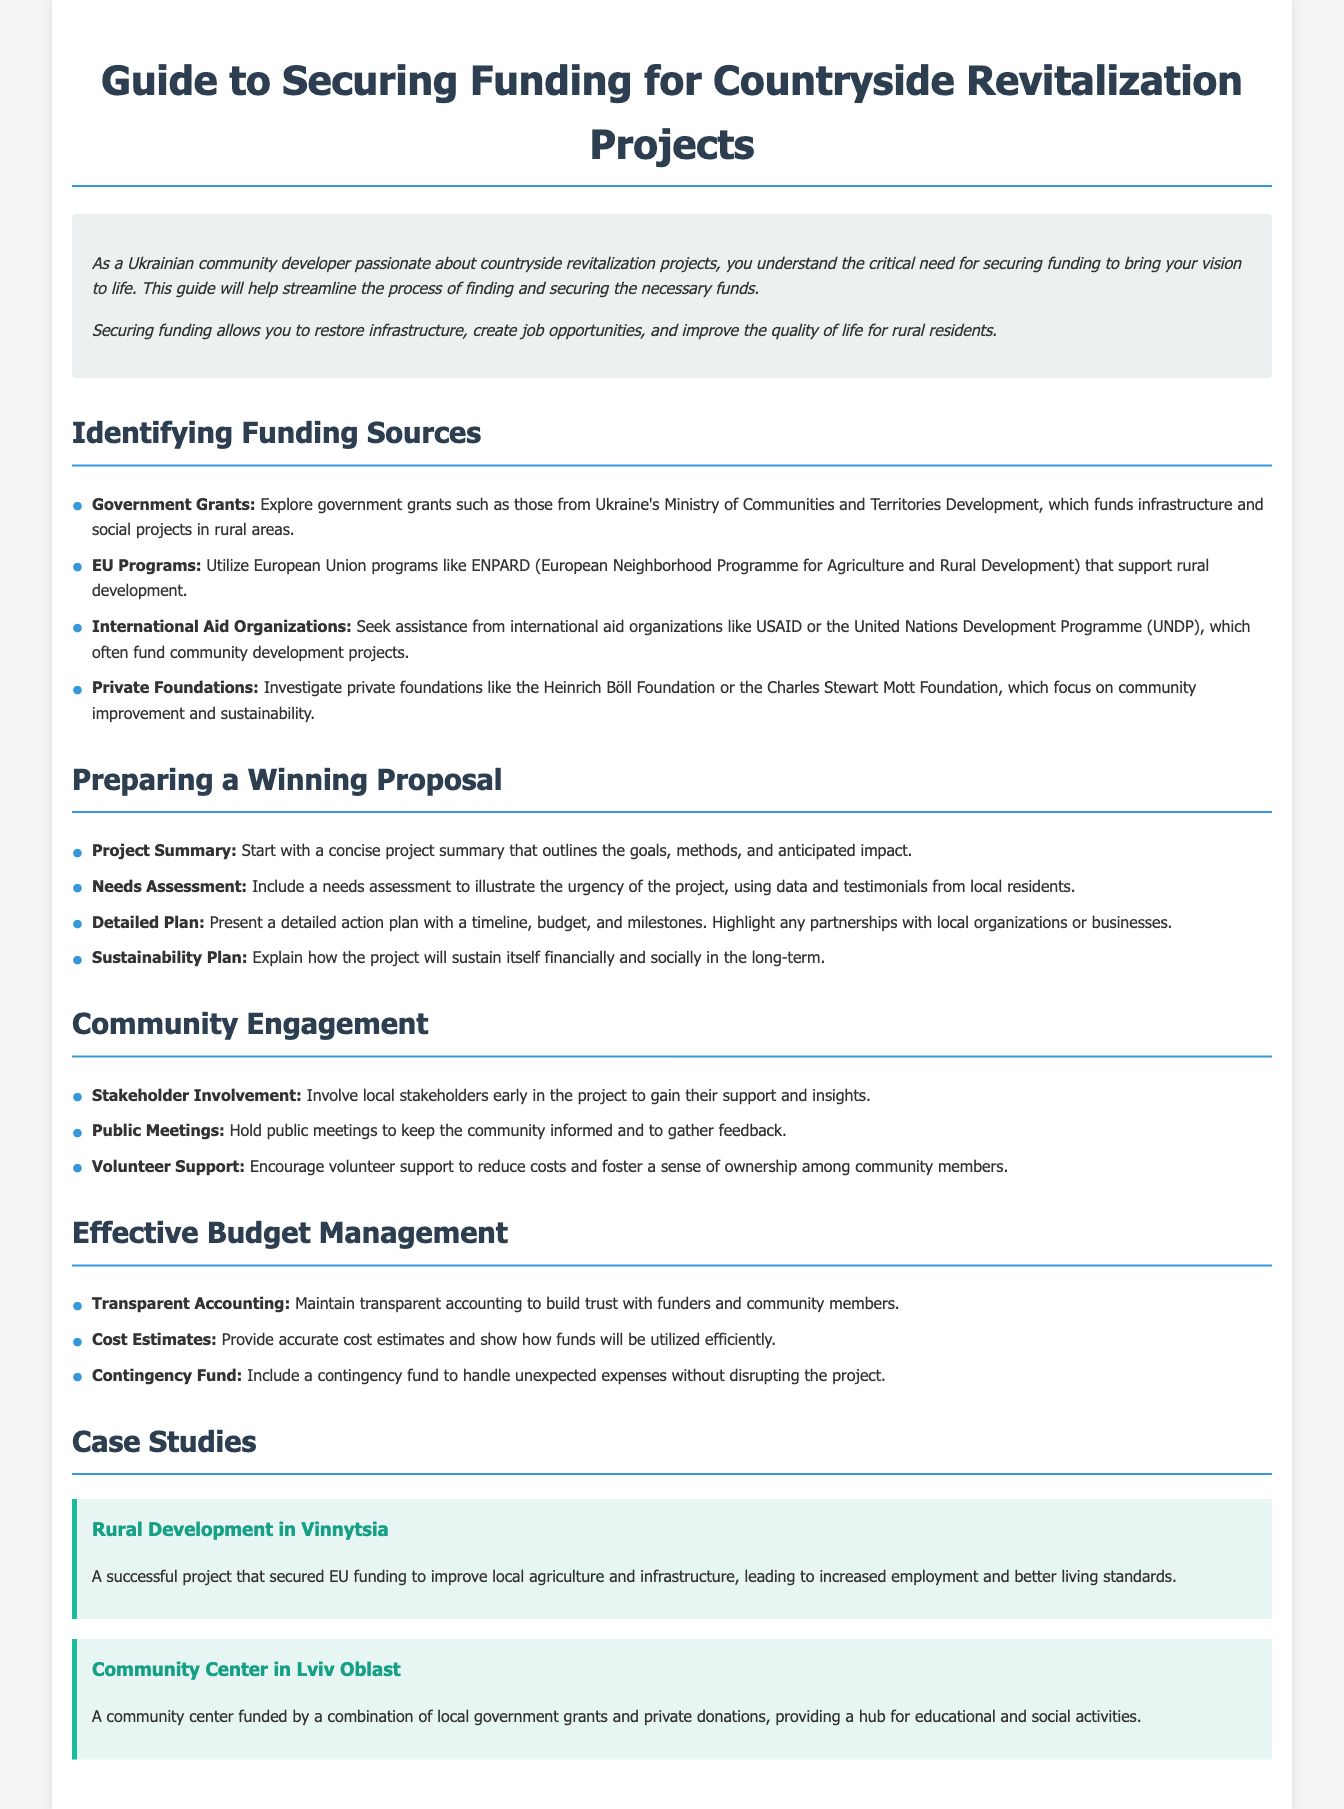What are the funding sources mentioned? The document lists several funding sources including government grants, EU programs, international aid organizations, and private foundations.
Answer: Government grants, EU programs, international aid organizations, private foundations What is one purpose of securing funding? The guide states that securing funding allows for the restoration of infrastructure, job creation, and improved quality of life.
Answer: Restore infrastructure What does the project summary need to include? The project summary should outline the goals, methods, and anticipated impact of the project.
Answer: Goals, methods, anticipated impact What should be assessed to illustrate project urgency? The needs assessment is meant to illustrate the urgency of the project using data and testimonials from local residents.
Answer: Needs assessment Which EU program is mentioned? The document mentions the European Neighborhood Programme for Agriculture and Rural Development (ENPARD) as a source of funding.
Answer: ENPARD How many case studies are provided? There are two case studies provided in the document regarding successful projects.
Answer: Two What should be included in the sustainability plan? The sustainability plan should explain how the project will sustain itself financially and socially in the long term.
Answer: Financial and social sustainability What is a strategy for community engagement? Involving local stakeholders early in the project is a key strategy for engagement mentioned in the document.
Answer: Stakeholder involvement What is one aspect of effective budget management? The guide emphasizes maintaining transparent accounting to build trust with funders and community members.
Answer: Transparent accounting 